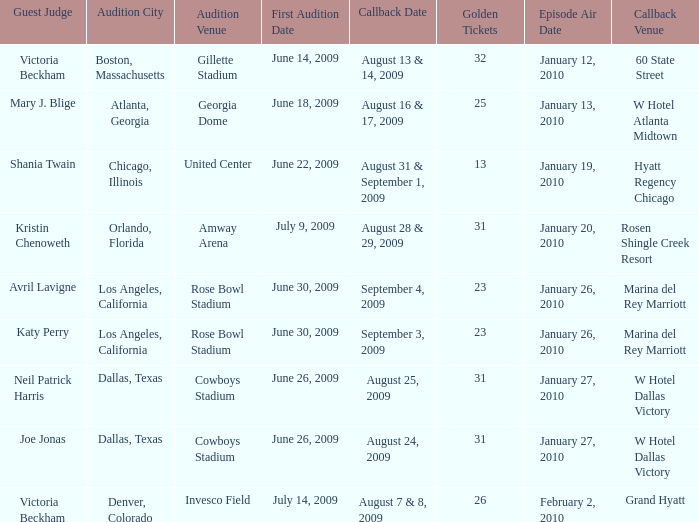Name the callback date for amway arena August 28 & 29, 2009. 